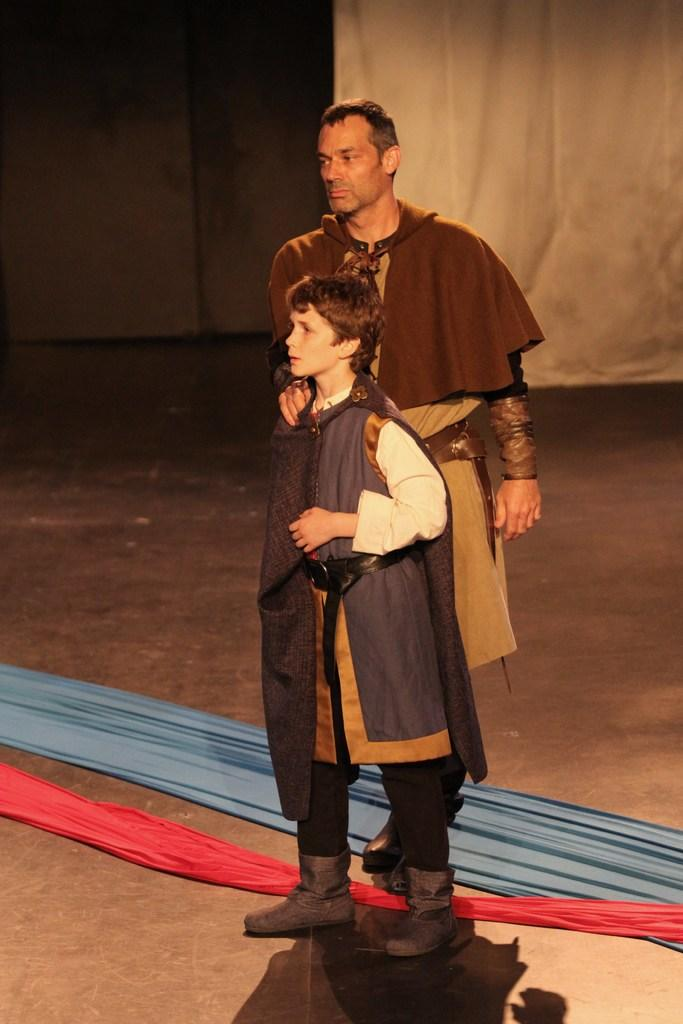Who is the main subject in the image? There is a boy in the image. What is the boy's position in relation to another person? The boy is standing in front of a man. Where are the boy and the man located? Both the boy and the man are on a stage. What can be seen in the background of the image? There are curtains in the background of the image. What type of frame is the boy holding in the image? There is no frame present in the image; the boy is not holding anything. Can you tell me what kind of guitar the man is playing in the image? There is no guitar present in the image; the man is not playing any musical instrument. 